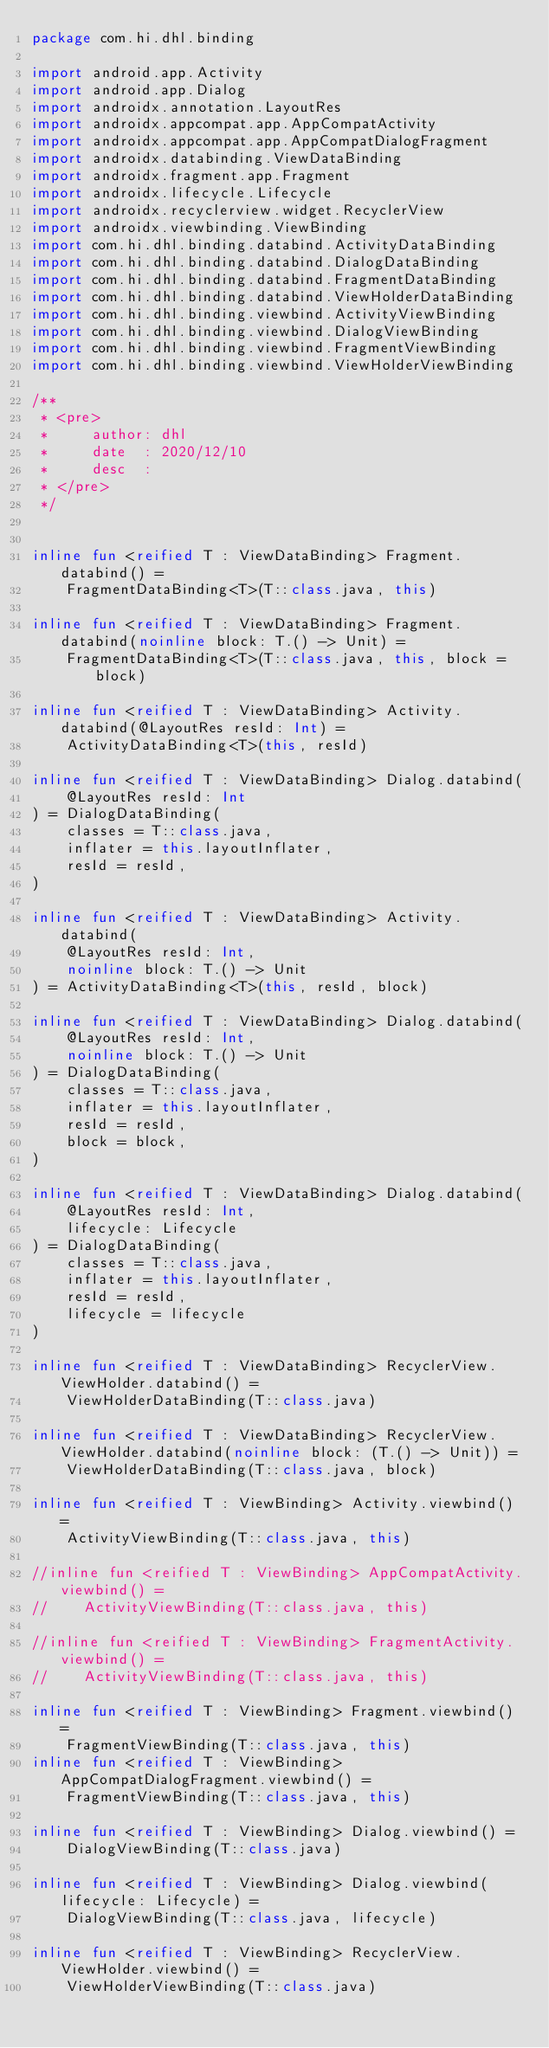<code> <loc_0><loc_0><loc_500><loc_500><_Kotlin_>package com.hi.dhl.binding

import android.app.Activity
import android.app.Dialog
import androidx.annotation.LayoutRes
import androidx.appcompat.app.AppCompatActivity
import androidx.appcompat.app.AppCompatDialogFragment
import androidx.databinding.ViewDataBinding
import androidx.fragment.app.Fragment
import androidx.lifecycle.Lifecycle
import androidx.recyclerview.widget.RecyclerView
import androidx.viewbinding.ViewBinding
import com.hi.dhl.binding.databind.ActivityDataBinding
import com.hi.dhl.binding.databind.DialogDataBinding
import com.hi.dhl.binding.databind.FragmentDataBinding
import com.hi.dhl.binding.databind.ViewHolderDataBinding
import com.hi.dhl.binding.viewbind.ActivityViewBinding
import com.hi.dhl.binding.viewbind.DialogViewBinding
import com.hi.dhl.binding.viewbind.FragmentViewBinding
import com.hi.dhl.binding.viewbind.ViewHolderViewBinding

/**
 * <pre>
 *     author: dhl
 *     date  : 2020/12/10
 *     desc  :
 * </pre>
 */


inline fun <reified T : ViewDataBinding> Fragment.databind() =
    FragmentDataBinding<T>(T::class.java, this)

inline fun <reified T : ViewDataBinding> Fragment.databind(noinline block: T.() -> Unit) =
    FragmentDataBinding<T>(T::class.java, this, block = block)

inline fun <reified T : ViewDataBinding> Activity.databind(@LayoutRes resId: Int) =
    ActivityDataBinding<T>(this, resId)

inline fun <reified T : ViewDataBinding> Dialog.databind(
    @LayoutRes resId: Int
) = DialogDataBinding(
    classes = T::class.java,
    inflater = this.layoutInflater,
    resId = resId,
)

inline fun <reified T : ViewDataBinding> Activity.databind(
    @LayoutRes resId: Int,
    noinline block: T.() -> Unit
) = ActivityDataBinding<T>(this, resId, block)

inline fun <reified T : ViewDataBinding> Dialog.databind(
    @LayoutRes resId: Int,
    noinline block: T.() -> Unit
) = DialogDataBinding(
    classes = T::class.java,
    inflater = this.layoutInflater,
    resId = resId,
    block = block,
)

inline fun <reified T : ViewDataBinding> Dialog.databind(
    @LayoutRes resId: Int,
    lifecycle: Lifecycle
) = DialogDataBinding(
    classes = T::class.java,
    inflater = this.layoutInflater,
    resId = resId,
    lifecycle = lifecycle
)

inline fun <reified T : ViewDataBinding> RecyclerView.ViewHolder.databind() =
    ViewHolderDataBinding(T::class.java)

inline fun <reified T : ViewDataBinding> RecyclerView.ViewHolder.databind(noinline block: (T.() -> Unit)) =
    ViewHolderDataBinding(T::class.java, block)

inline fun <reified T : ViewBinding> Activity.viewbind() =
    ActivityViewBinding(T::class.java, this)

//inline fun <reified T : ViewBinding> AppCompatActivity.viewbind() =
//    ActivityViewBinding(T::class.java, this)

//inline fun <reified T : ViewBinding> FragmentActivity.viewbind() =
//    ActivityViewBinding(T::class.java, this)

inline fun <reified T : ViewBinding> Fragment.viewbind() =
    FragmentViewBinding(T::class.java, this)
inline fun <reified T : ViewBinding> AppCompatDialogFragment.viewbind() =
    FragmentViewBinding(T::class.java, this)

inline fun <reified T : ViewBinding> Dialog.viewbind() =
    DialogViewBinding(T::class.java)

inline fun <reified T : ViewBinding> Dialog.viewbind(lifecycle: Lifecycle) =
    DialogViewBinding(T::class.java, lifecycle)

inline fun <reified T : ViewBinding> RecyclerView.ViewHolder.viewbind() =
    ViewHolderViewBinding(T::class.java)</code> 